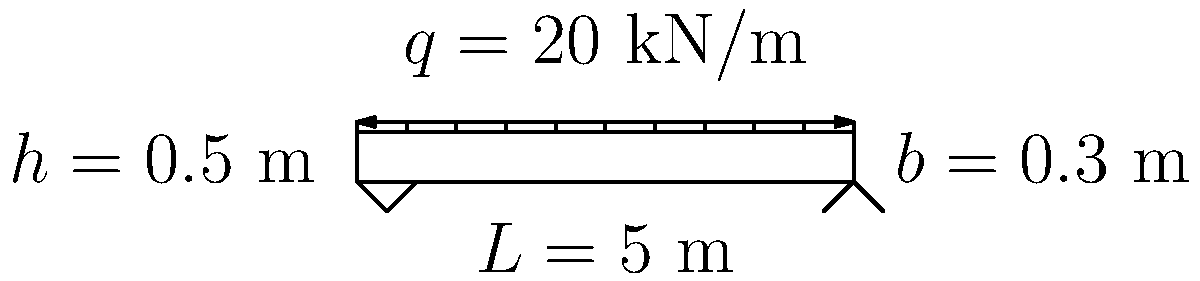A simply supported concrete beam has a length of 5 m, width of 0.3 m, and height of 0.5 m. The beam is subjected to a uniformly distributed load of 20 kN/m along its entire length. Given that the concrete has a compressive strength ($f_c'$) of 30 MPa and a modulus of elasticity ($E$) of 25 GPa, calculate the maximum bending stress ($\sigma_{max}$) in the beam. Assume linear elastic behavior and neglect the beam's self-weight. To calculate the maximum bending stress, we'll follow these steps:

1. Calculate the moment of inertia ($I$):
   $I = \frac{1}{12} bh^3 = \frac{1}{12} \cdot 0.3 \cdot 0.5^3 = 3.125 \times 10^{-3}$ m⁴

2. Determine the maximum bending moment ($M_{max}$):
   For a simply supported beam with uniformly distributed load:
   $M_{max} = \frac{qL^2}{8} = \frac{20 \cdot 5^2}{8} = 62.5$ kN·m

3. Calculate the distance from the neutral axis to the extreme fiber ($y$):
   $y = \frac{h}{2} = \frac{0.5}{2} = 0.25$ m

4. Apply the flexure formula to find the maximum bending stress:
   $$\sigma_{max} = \frac{M_{max} \cdot y}{I} = \frac{62.5 \times 10^3 \cdot 0.25}{3.125 \times 10^{-3}} = 5 \times 10^6$$ Pa = 5 MPa

Therefore, the maximum bending stress in the beam is 5 MPa.
Answer: 5 MPa 